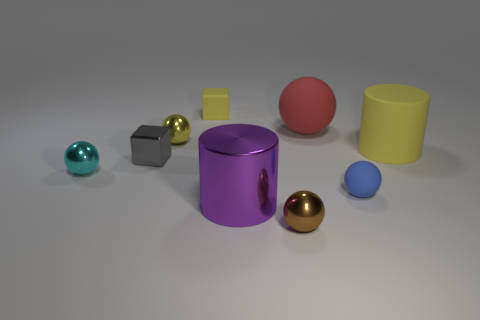Subtract all tiny yellow metal spheres. How many spheres are left? 4 Subtract all brown balls. How many balls are left? 4 Subtract 1 cubes. How many cubes are left? 1 Subtract all spheres. How many objects are left? 4 Subtract 1 yellow blocks. How many objects are left? 8 Subtract all gray cylinders. Subtract all yellow cubes. How many cylinders are left? 2 Subtract all tiny brown objects. Subtract all big objects. How many objects are left? 5 Add 2 big shiny cylinders. How many big shiny cylinders are left? 3 Add 9 large metal objects. How many large metal objects exist? 10 